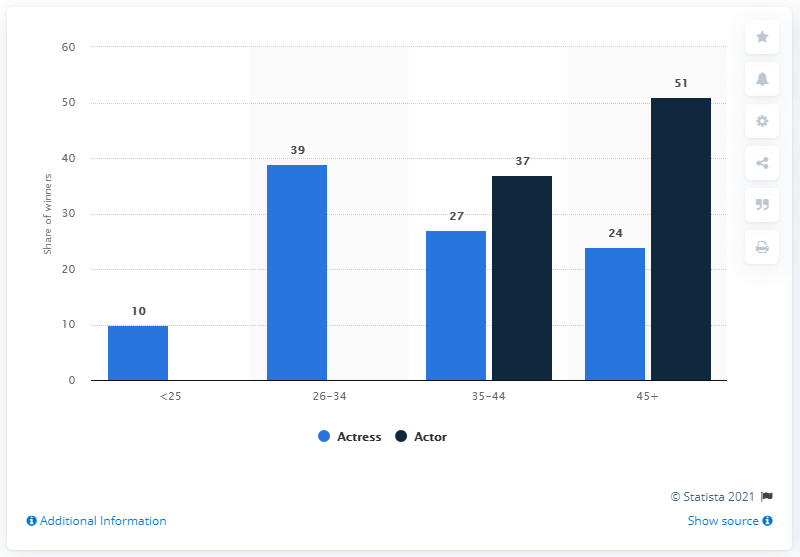Mention a couple of crucial points in this snapshot. As of March 2014, it was found that 51% of actors who have won an Academy Award were aged 45 or older. 